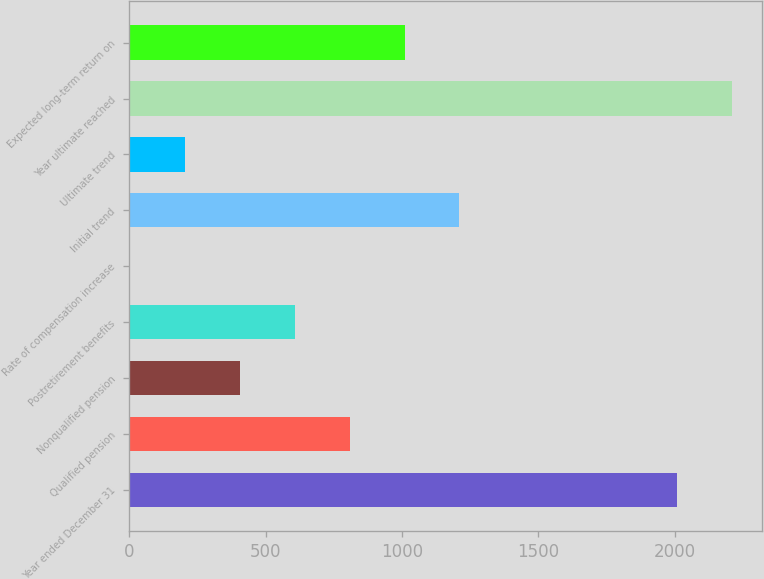Convert chart. <chart><loc_0><loc_0><loc_500><loc_500><bar_chart><fcel>Year ended December 31<fcel>Qualified pension<fcel>Nonqualified pension<fcel>Postretirement benefits<fcel>Rate of compensation increase<fcel>Initial trend<fcel>Ultimate trend<fcel>Year ultimate reached<fcel>Expected long-term return on<nl><fcel>2009<fcel>808<fcel>406<fcel>607<fcel>4<fcel>1210<fcel>205<fcel>2210<fcel>1009<nl></chart> 